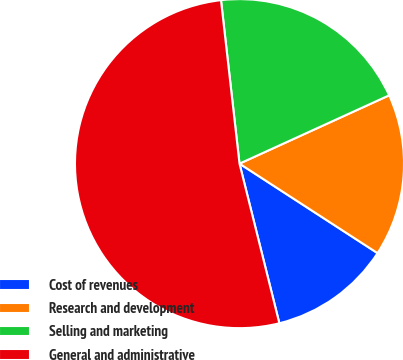<chart> <loc_0><loc_0><loc_500><loc_500><pie_chart><fcel>Cost of revenues<fcel>Research and development<fcel>Selling and marketing<fcel>General and administrative<nl><fcel>11.95%<fcel>15.97%<fcel>19.98%<fcel>52.1%<nl></chart> 